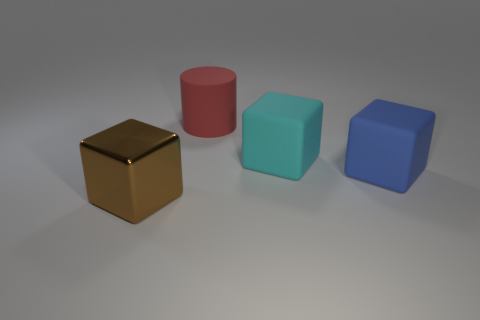Do the large block on the right side of the large cyan matte cube and the big cyan object behind the blue thing have the same material?
Your answer should be compact. Yes. Are there any tiny red matte cylinders?
Your response must be concise. No. Is the number of large matte blocks right of the cyan thing greater than the number of big cyan blocks to the left of the big brown metal cube?
Your answer should be very brief. Yes. There is a large blue object that is the same shape as the big cyan thing; what is its material?
Make the answer very short. Rubber. What is the shape of the large red matte object?
Ensure brevity in your answer.  Cylinder. Is the number of red cylinders that are on the left side of the large matte cylinder greater than the number of shiny things?
Make the answer very short. No. The thing behind the big cyan rubber object has what shape?
Your answer should be compact. Cylinder. How many other things are the same shape as the big red matte thing?
Provide a short and direct response. 0. Do the cube that is on the left side of the big red matte cylinder and the red thing have the same material?
Ensure brevity in your answer.  No. Are there the same number of large brown shiny objects on the right side of the big cyan rubber thing and blue matte cubes behind the brown metallic block?
Ensure brevity in your answer.  No. 